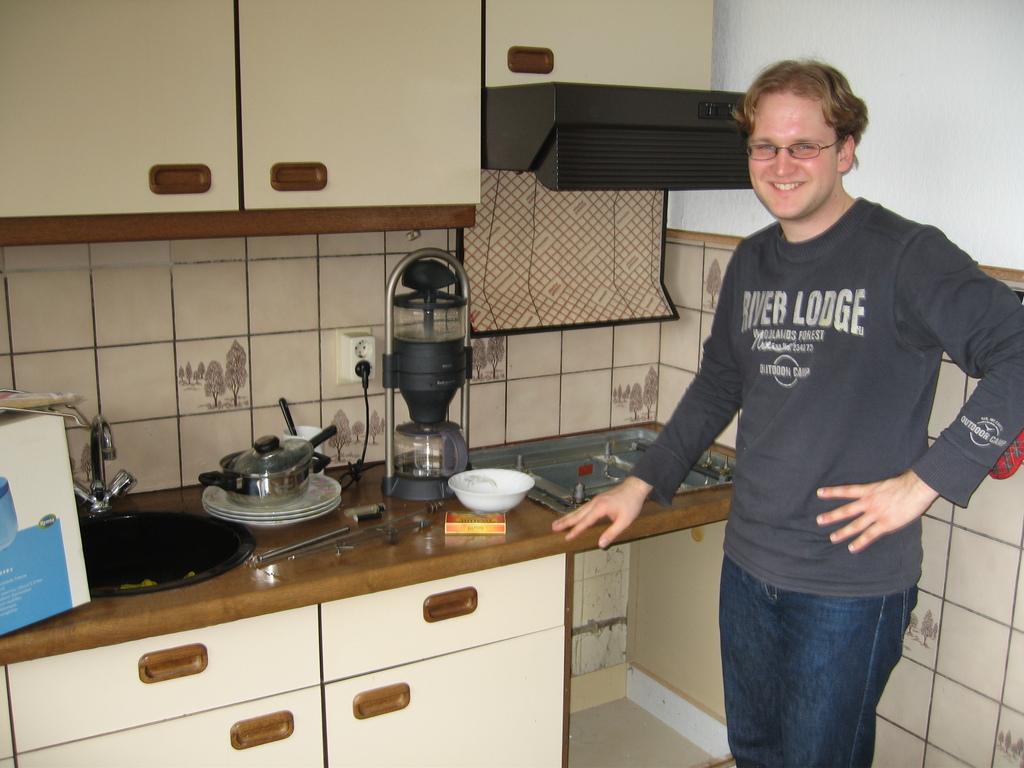What lodge did this man's shirt come from?
Your answer should be very brief. River lodge. 